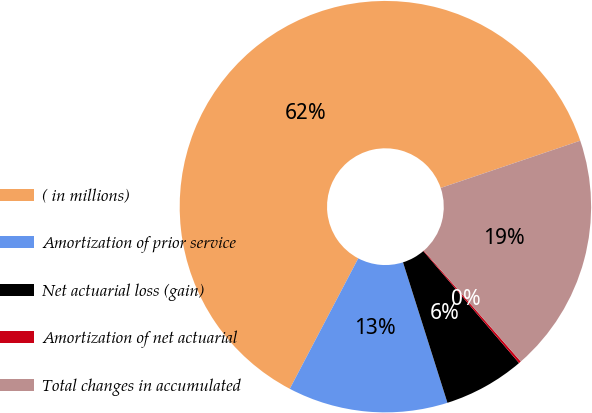Convert chart. <chart><loc_0><loc_0><loc_500><loc_500><pie_chart><fcel>( in millions)<fcel>Amortization of prior service<fcel>Net actuarial loss (gain)<fcel>Amortization of net actuarial<fcel>Total changes in accumulated<nl><fcel>62.11%<fcel>12.57%<fcel>6.38%<fcel>0.18%<fcel>18.76%<nl></chart> 